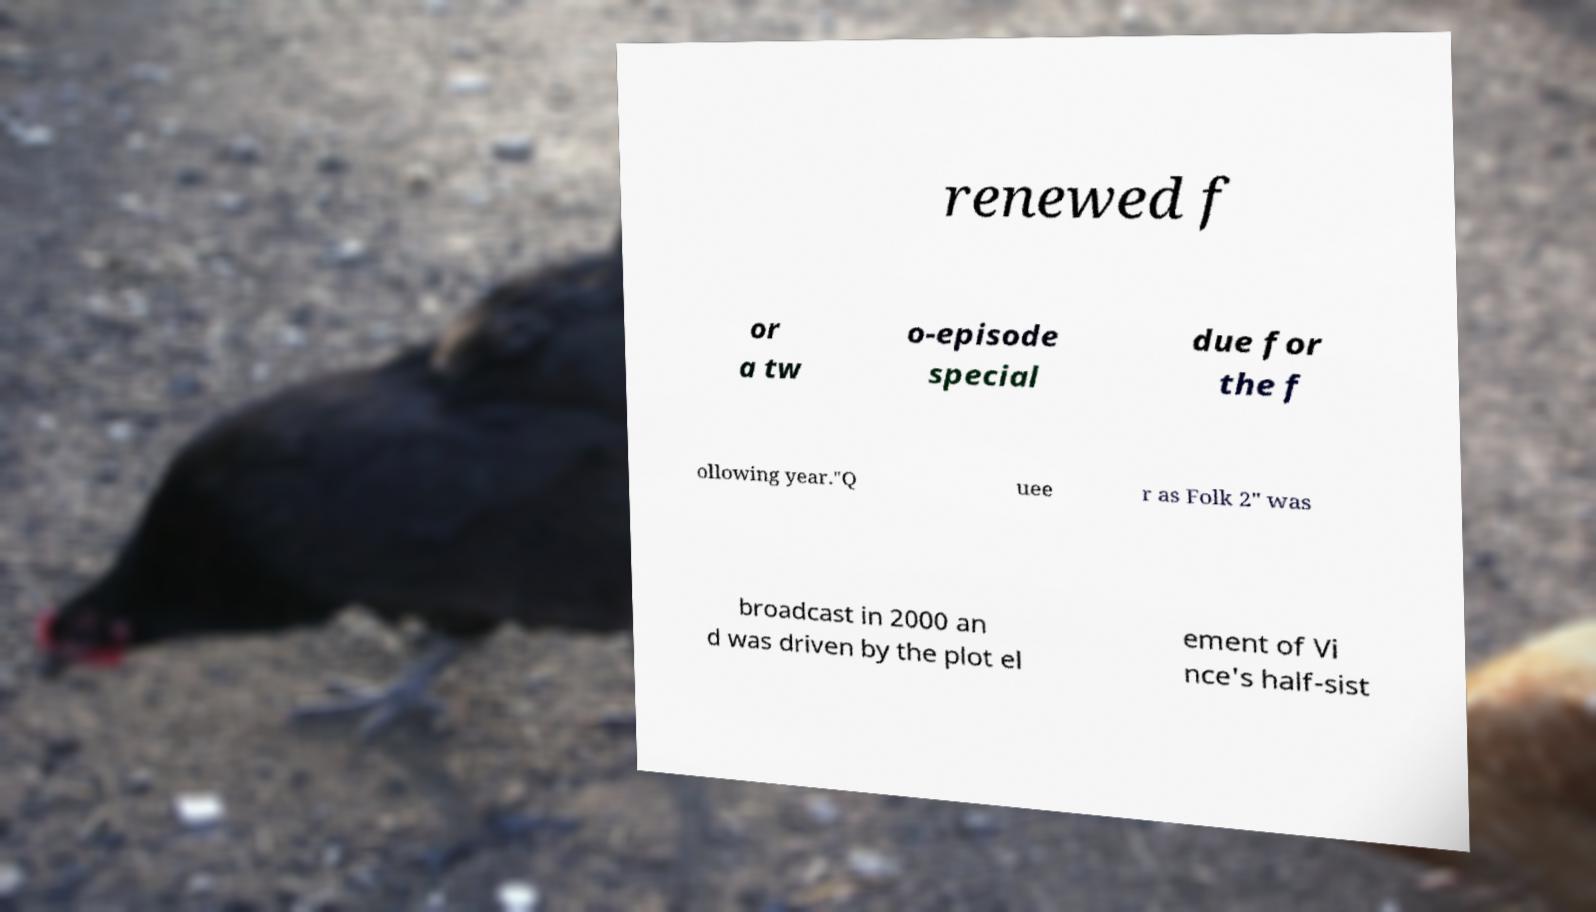Could you assist in decoding the text presented in this image and type it out clearly? renewed f or a tw o-episode special due for the f ollowing year."Q uee r as Folk 2" was broadcast in 2000 an d was driven by the plot el ement of Vi nce's half-sist 